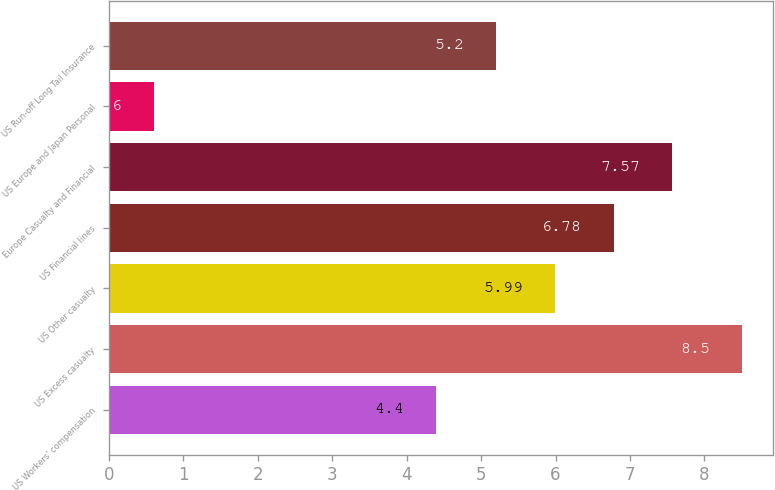Convert chart to OTSL. <chart><loc_0><loc_0><loc_500><loc_500><bar_chart><fcel>US Workers' compensation<fcel>US Excess casualty<fcel>US Other casualty<fcel>US Financial lines<fcel>Europe Casualty and Financial<fcel>US Europe and Japan Personal<fcel>US Run-off Long Tail Insurance<nl><fcel>4.4<fcel>8.5<fcel>5.99<fcel>6.78<fcel>7.57<fcel>0.6<fcel>5.2<nl></chart> 